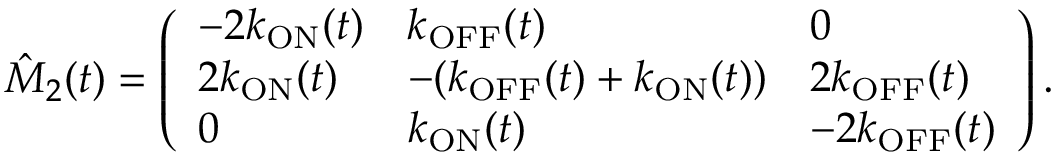<formula> <loc_0><loc_0><loc_500><loc_500>\hat { M } _ { 2 } ( t ) = \left ( \begin{array} { l l l } { - 2 k _ { O N } ( t ) } & { k _ { O F F } ( t ) } & { 0 } \\ { 2 k _ { O N } ( t ) } & { - ( k _ { O F F } ( t ) + k _ { O N } ( t ) ) } & { 2 k _ { O F F } ( t ) } \\ { 0 } & { k _ { O N } ( t ) } & { - 2 k _ { O F F } ( t ) } \end{array} \right ) .</formula> 